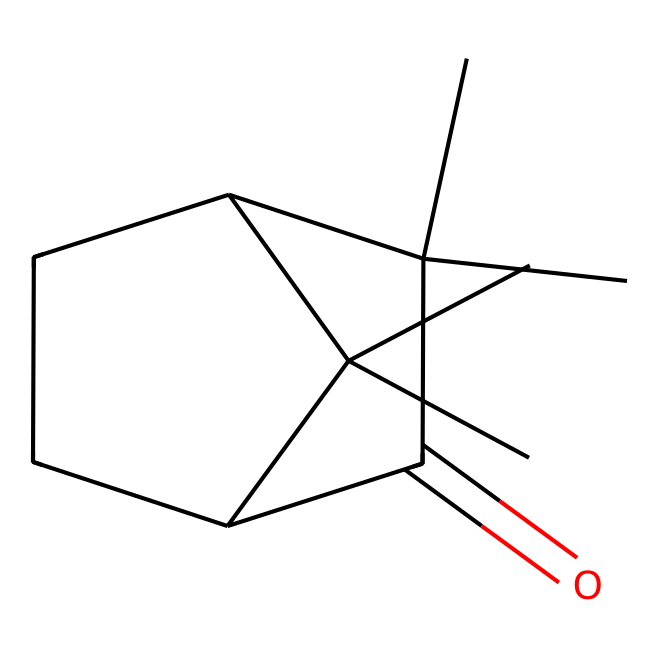What is the main functional group present in camphor? The chemical structure reveals a carbonyl group (C=O), which is the defining feature of ketones.
Answer: carbonyl group How many carbon atoms are present in camphor? By analyzing the SMILES representation, we can count a total of 10 carbon atoms in the structure.
Answer: 10 What type of compound is camphor specifically categorized as? Camphor is identified as a ketone due to the presence of the carbonyl functional group and its structural characteristics.
Answer: ketone Which cyclic structures are visible in the molecular structure of camphor? The structure includes two cyclohexane rings, indicating it has multiple cyclic components.
Answer: two cyclohexane rings What is the degree of saturation of camphor? The structure has a carbonyl group and no additional double bonds beyond the ones required for saturation; therefore, it is saturated except for the ketone.
Answer: saturated How many total double bonds does camphor contain? The SMILES structure shows one double bond, which is present in the carbonyl group, and no other double bonds are evident.
Answer: one What type of interactions could the carbonyl group in camphor likely participate in? The carbonyl can engage in hydrogen bonding due to its polar nature, interacting with suitable hydrogen donors.
Answer: hydrogen bonding 